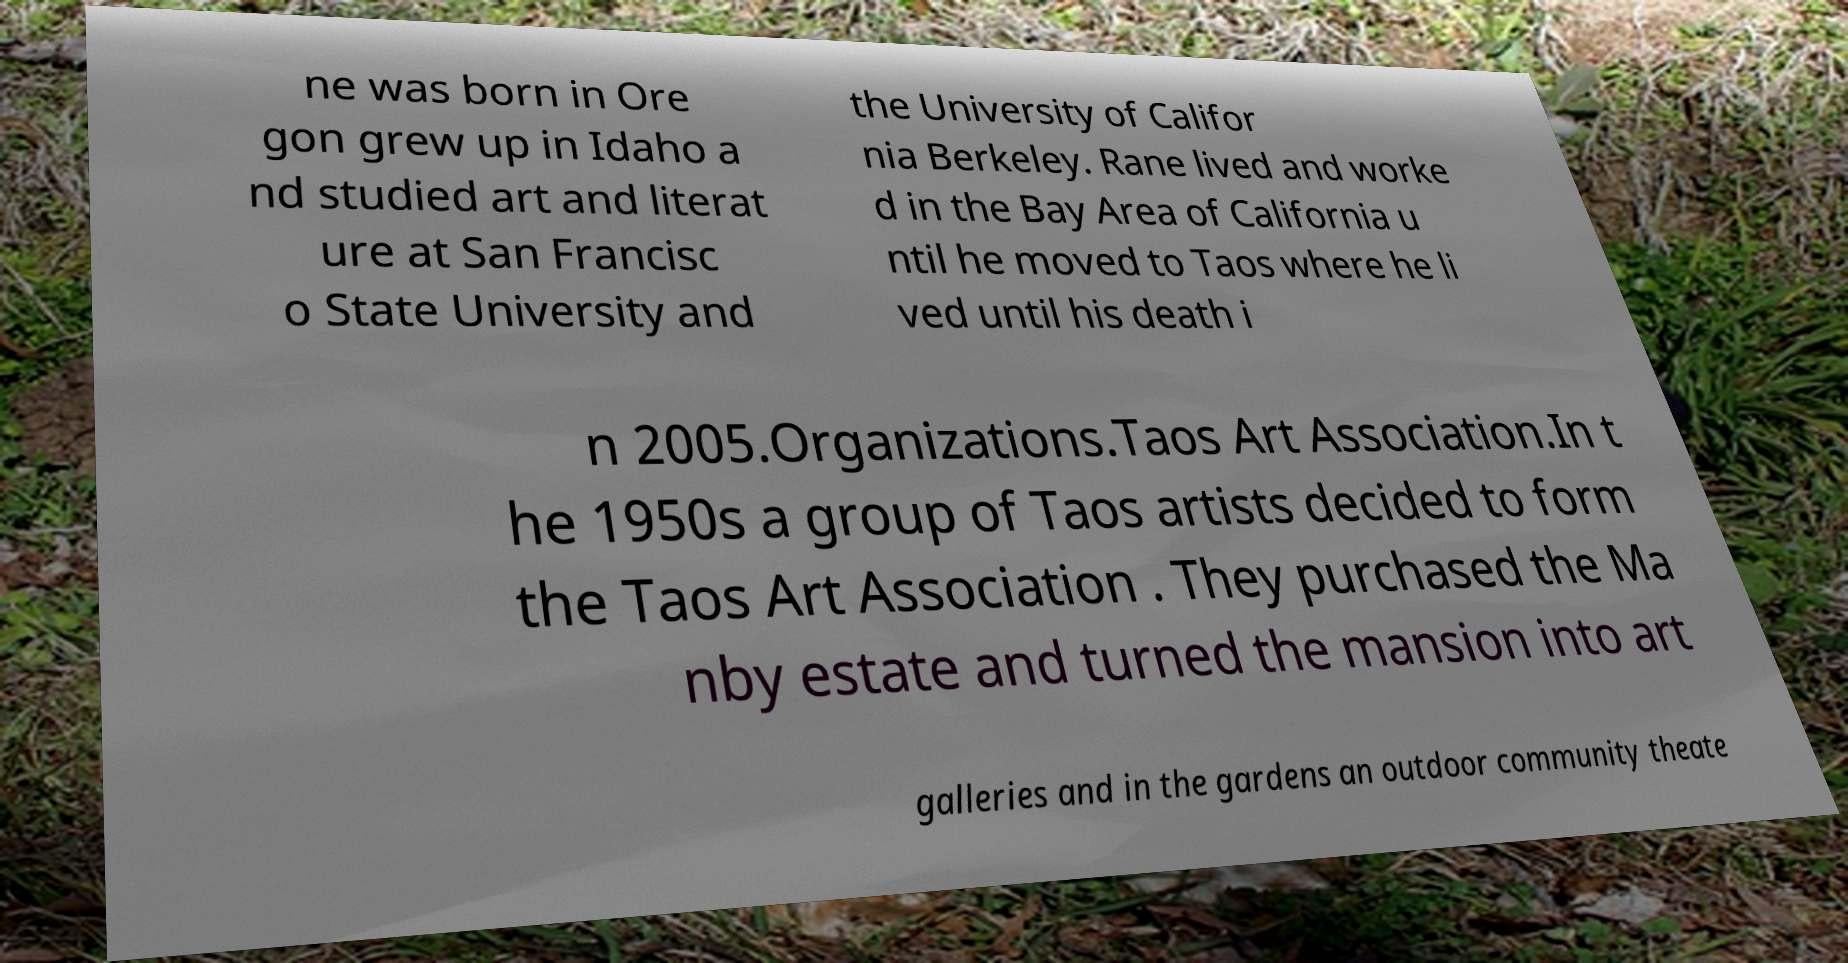Please read and relay the text visible in this image. What does it say? ne was born in Ore gon grew up in Idaho a nd studied art and literat ure at San Francisc o State University and the University of Califor nia Berkeley. Rane lived and worke d in the Bay Area of California u ntil he moved to Taos where he li ved until his death i n 2005.Organizations.Taos Art Association.In t he 1950s a group of Taos artists decided to form the Taos Art Association . They purchased the Ma nby estate and turned the mansion into art galleries and in the gardens an outdoor community theate 